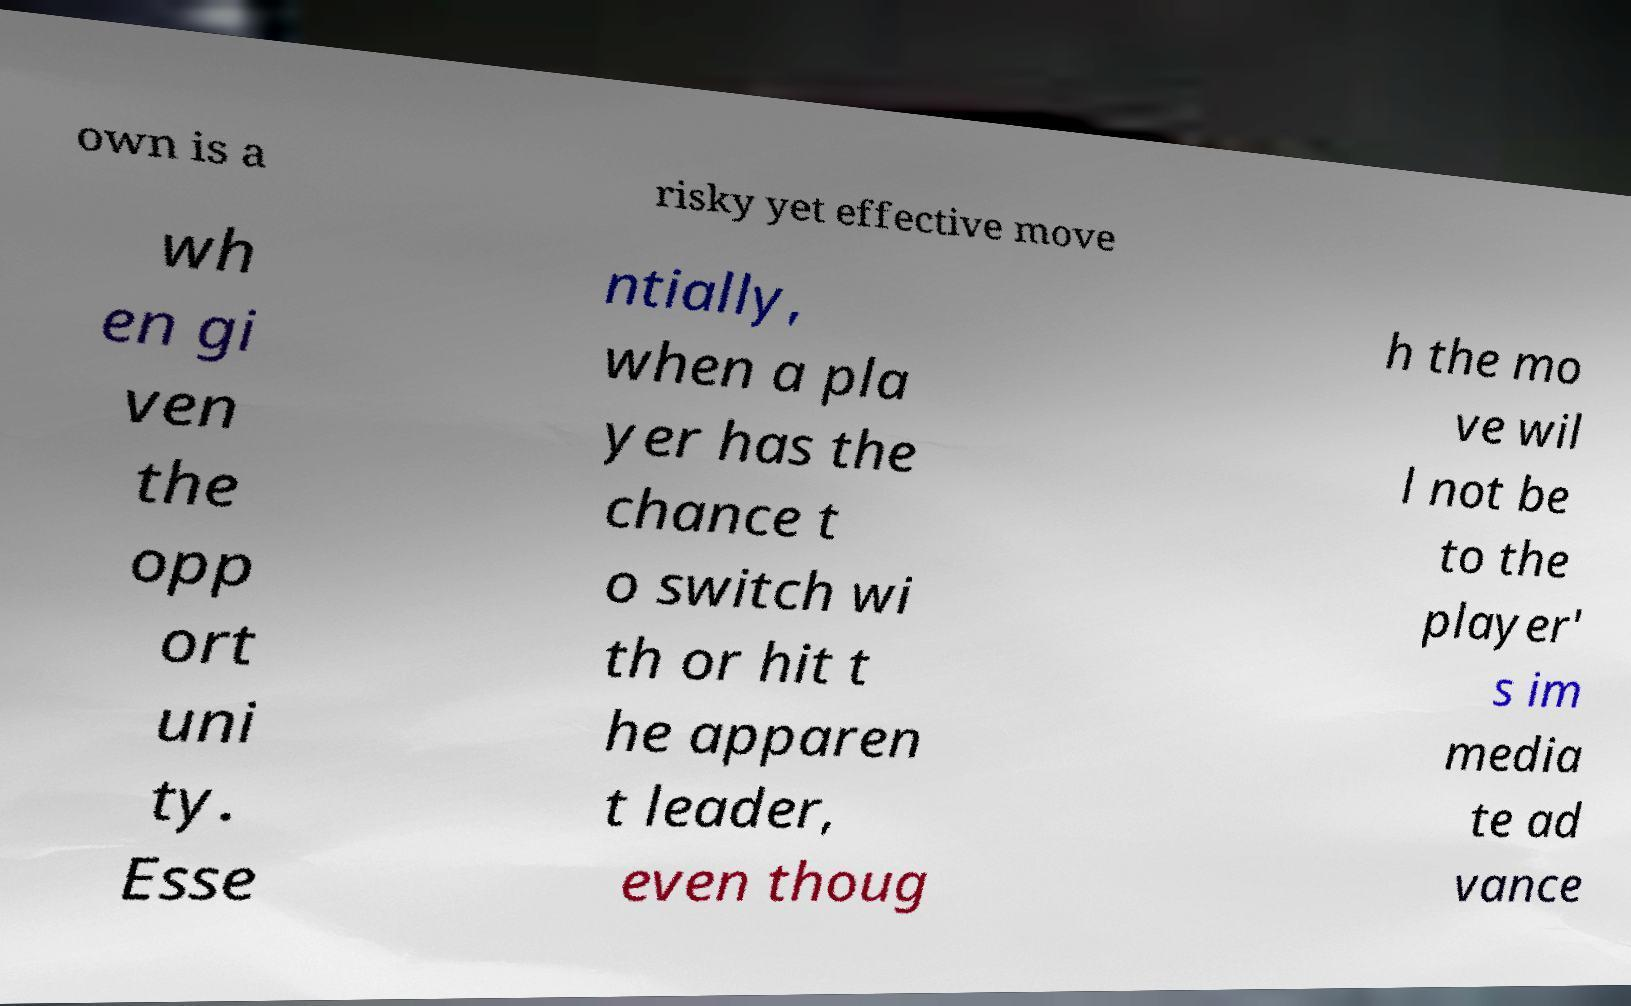Could you extract and type out the text from this image? own is a risky yet effective move wh en gi ven the opp ort uni ty. Esse ntially, when a pla yer has the chance t o switch wi th or hit t he apparen t leader, even thoug h the mo ve wil l not be to the player' s im media te ad vance 